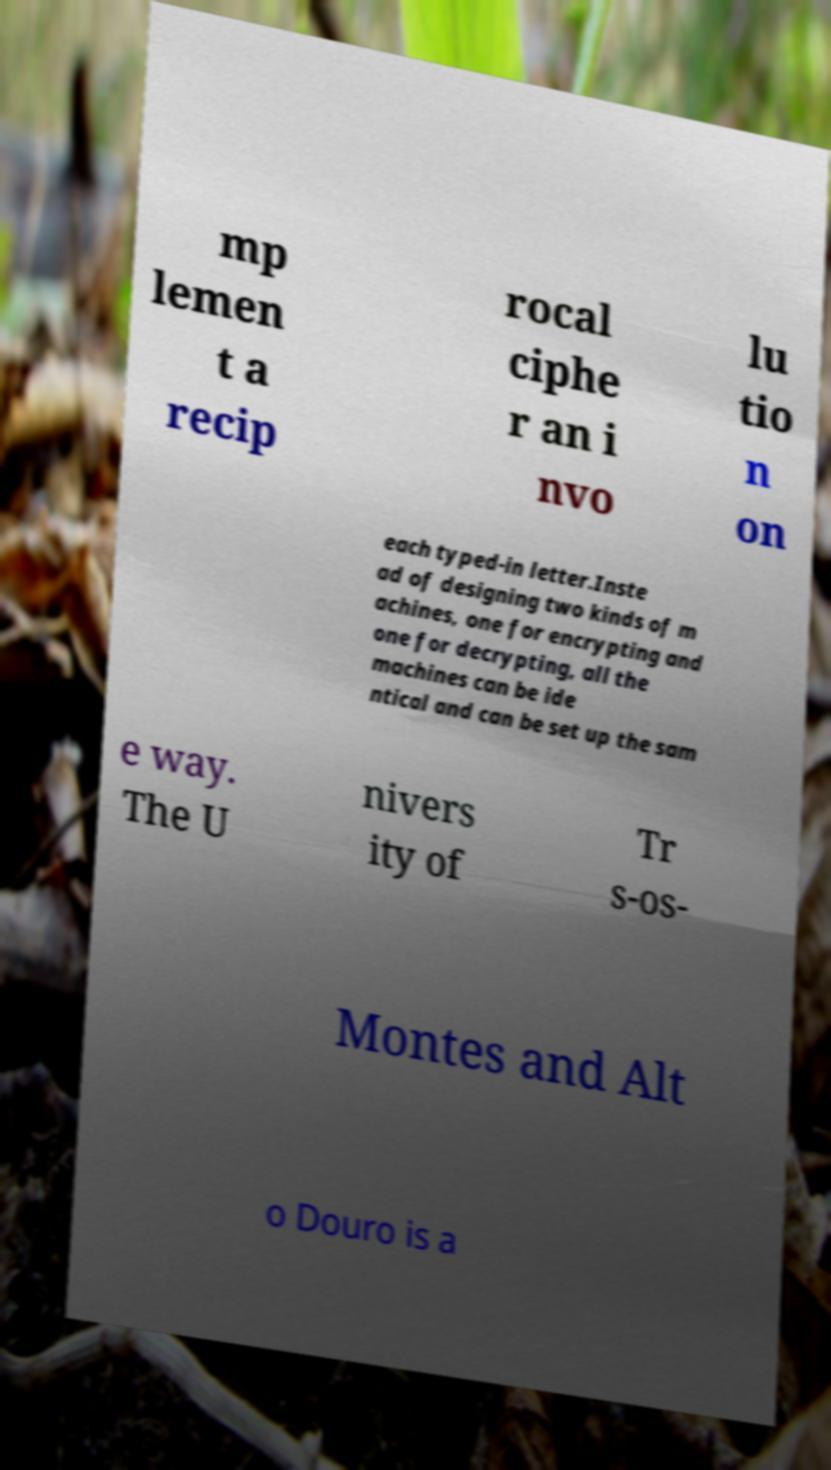I need the written content from this picture converted into text. Can you do that? mp lemen t a recip rocal ciphe r an i nvo lu tio n on each typed-in letter.Inste ad of designing two kinds of m achines, one for encrypting and one for decrypting, all the machines can be ide ntical and can be set up the sam e way. The U nivers ity of Tr s-os- Montes and Alt o Douro is a 